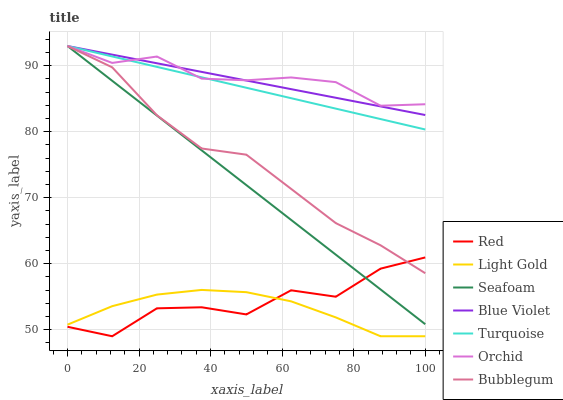Does Seafoam have the minimum area under the curve?
Answer yes or no. No. Does Seafoam have the maximum area under the curve?
Answer yes or no. No. Is Bubblegum the smoothest?
Answer yes or no. No. Is Bubblegum the roughest?
Answer yes or no. No. Does Seafoam have the lowest value?
Answer yes or no. No. Does Red have the highest value?
Answer yes or no. No. Is Red less than Orchid?
Answer yes or no. Yes. Is Seafoam greater than Light Gold?
Answer yes or no. Yes. Does Red intersect Orchid?
Answer yes or no. No. 